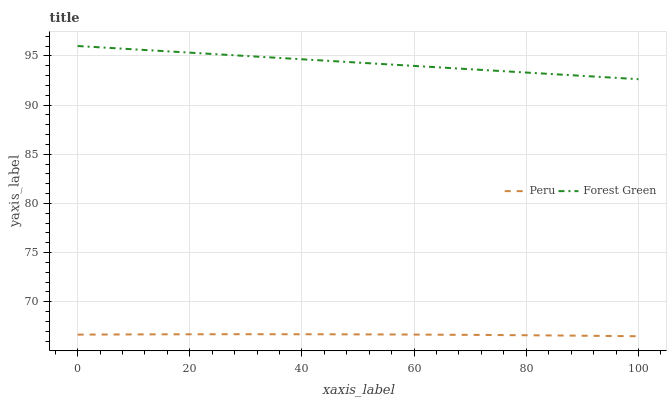Does Peru have the minimum area under the curve?
Answer yes or no. Yes. Does Forest Green have the maximum area under the curve?
Answer yes or no. Yes. Does Peru have the maximum area under the curve?
Answer yes or no. No. Is Forest Green the smoothest?
Answer yes or no. Yes. Is Peru the roughest?
Answer yes or no. Yes. Is Peru the smoothest?
Answer yes or no. No. Does Peru have the lowest value?
Answer yes or no. Yes. Does Forest Green have the highest value?
Answer yes or no. Yes. Does Peru have the highest value?
Answer yes or no. No. Is Peru less than Forest Green?
Answer yes or no. Yes. Is Forest Green greater than Peru?
Answer yes or no. Yes. Does Peru intersect Forest Green?
Answer yes or no. No. 